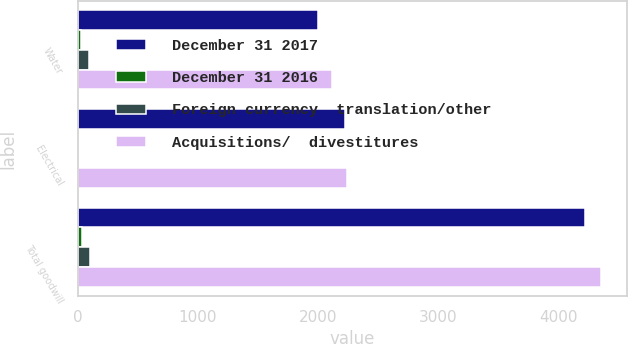Convert chart to OTSL. <chart><loc_0><loc_0><loc_500><loc_500><stacked_bar_chart><ecel><fcel>Water<fcel>Electrical<fcel>Total goodwill<nl><fcel>December 31 2017<fcel>1994.6<fcel>2222.8<fcel>4217.4<nl><fcel>December 31 2016<fcel>27.3<fcel>5.3<fcel>32.6<nl><fcel>Foreign currency  translation/other<fcel>91<fcel>10.1<fcel>101.1<nl><fcel>Acquisitions/  divestitures<fcel>2112.9<fcel>2238.2<fcel>4351.1<nl></chart> 